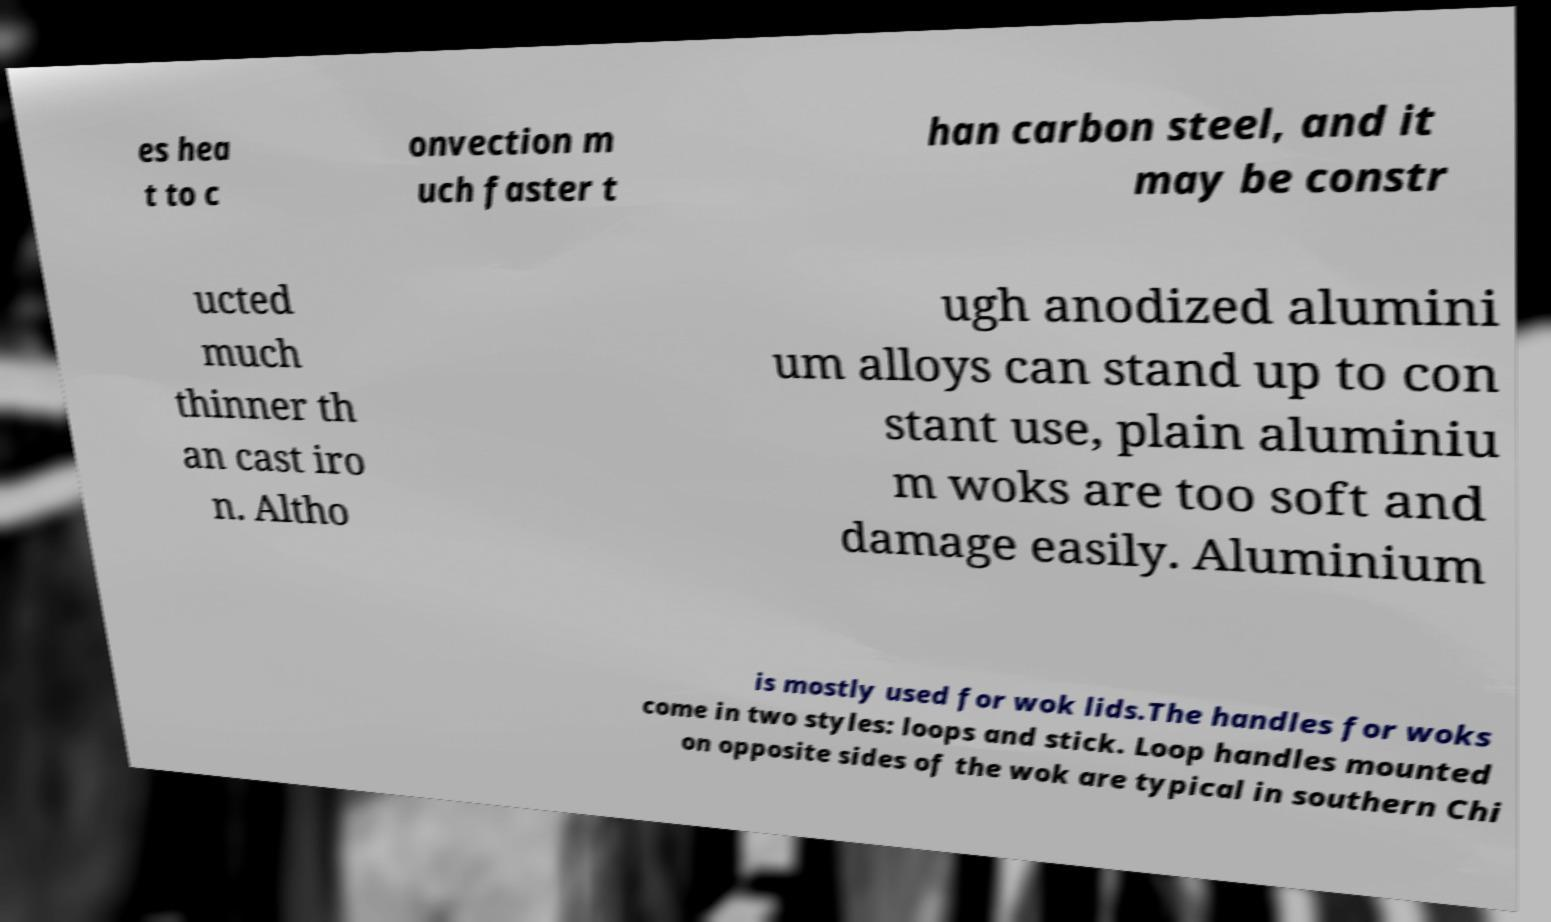Please read and relay the text visible in this image. What does it say? es hea t to c onvection m uch faster t han carbon steel, and it may be constr ucted much thinner th an cast iro n. Altho ugh anodized alumini um alloys can stand up to con stant use, plain aluminiu m woks are too soft and damage easily. Aluminium is mostly used for wok lids.The handles for woks come in two styles: loops and stick. Loop handles mounted on opposite sides of the wok are typical in southern Chi 